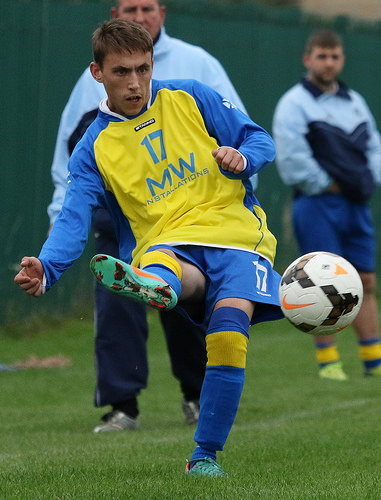<image>
Is the shoe behind the ball? Yes. From this viewpoint, the shoe is positioned behind the ball, with the ball partially or fully occluding the shoe. 